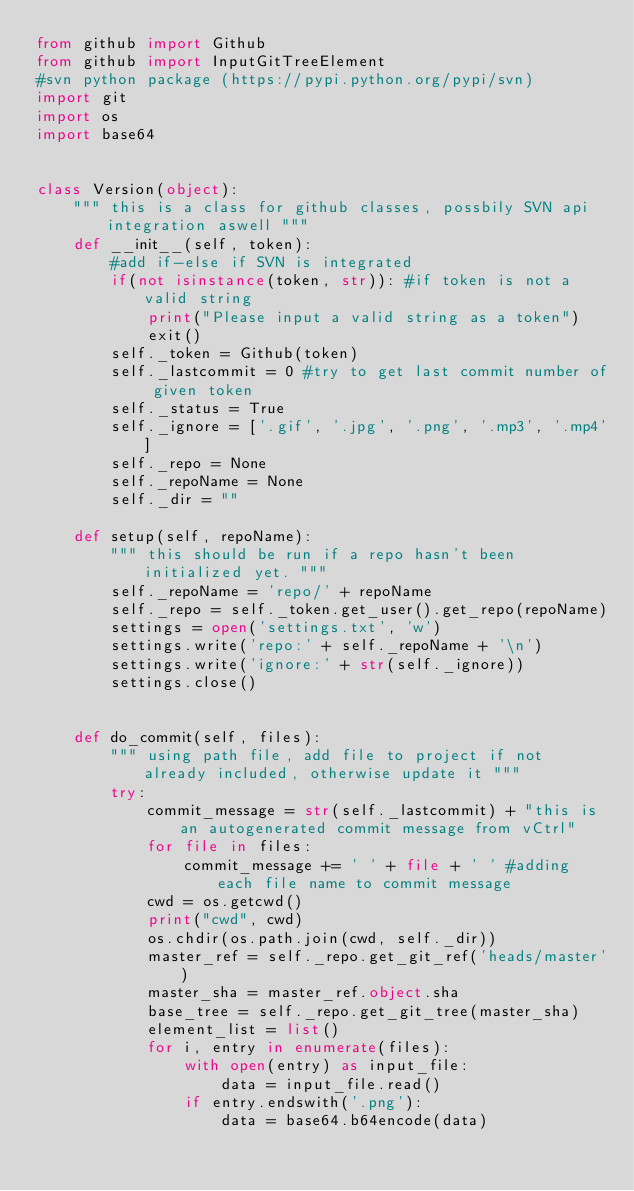<code> <loc_0><loc_0><loc_500><loc_500><_Python_>from github import Github  
from github import InputGitTreeElement
#svn python package (https://pypi.python.org/pypi/svn)
import git
import os
import base64


class Version(object):
    """ this is a class for github classes, possbily SVN api integration aswell """
    def __init__(self, token):
        #add if-else if SVN is integrated
        if(not isinstance(token, str)): #if token is not a valid string
            print("Please input a valid string as a token")
            exit()
        self._token = Github(token)
        self._lastcommit = 0 #try to get last commit number of given token 
        self._status = True
        self._ignore = ['.gif', '.jpg', '.png', '.mp3', '.mp4']
        self._repo = None
        self._repoName = None
        self._dir = ""

    def setup(self, repoName):
        """ this should be run if a repo hasn't been initialized yet. """
        self._repoName = 'repo/' + repoName
        self._repo = self._token.get_user().get_repo(repoName)
        settings = open('settings.txt', 'w')
        settings.write('repo:' + self._repoName + '\n')
        settings.write('ignore:' + str(self._ignore))
        settings.close()

    
    def do_commit(self, files):
        """ using path file, add file to project if not already included, otherwise update it """
        try:
            commit_message = str(self._lastcommit) + "this is an autogenerated commit message from vCtrl"
            for file in files:
                commit_message += ' ' + file + ' ' #adding each file name to commit message
            cwd = os.getcwd()
            print("cwd", cwd)
            os.chdir(os.path.join(cwd, self._dir))
            master_ref = self._repo.get_git_ref('heads/master')
            master_sha = master_ref.object.sha
            base_tree = self._repo.get_git_tree(master_sha)
            element_list = list()
            for i, entry in enumerate(files):
                with open(entry) as input_file:
                    data = input_file.read()
                if entry.endswith('.png'):
                    data = base64.b64encode(data)</code> 